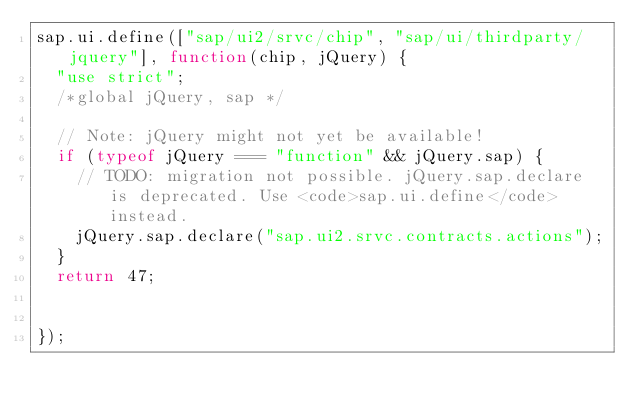<code> <loc_0><loc_0><loc_500><loc_500><_JavaScript_>sap.ui.define(["sap/ui2/srvc/chip", "sap/ui/thirdparty/jquery"], function(chip, jQuery) {
  "use strict";
  /*global jQuery, sap */

  // Note: jQuery might not yet be available!
  if (typeof jQuery === "function" && jQuery.sap) {
    // TODO: migration not possible. jQuery.sap.declare is deprecated. Use <code>sap.ui.define</code> instead.
    jQuery.sap.declare("sap.ui2.srvc.contracts.actions");
  }
  return 47;


});</code> 